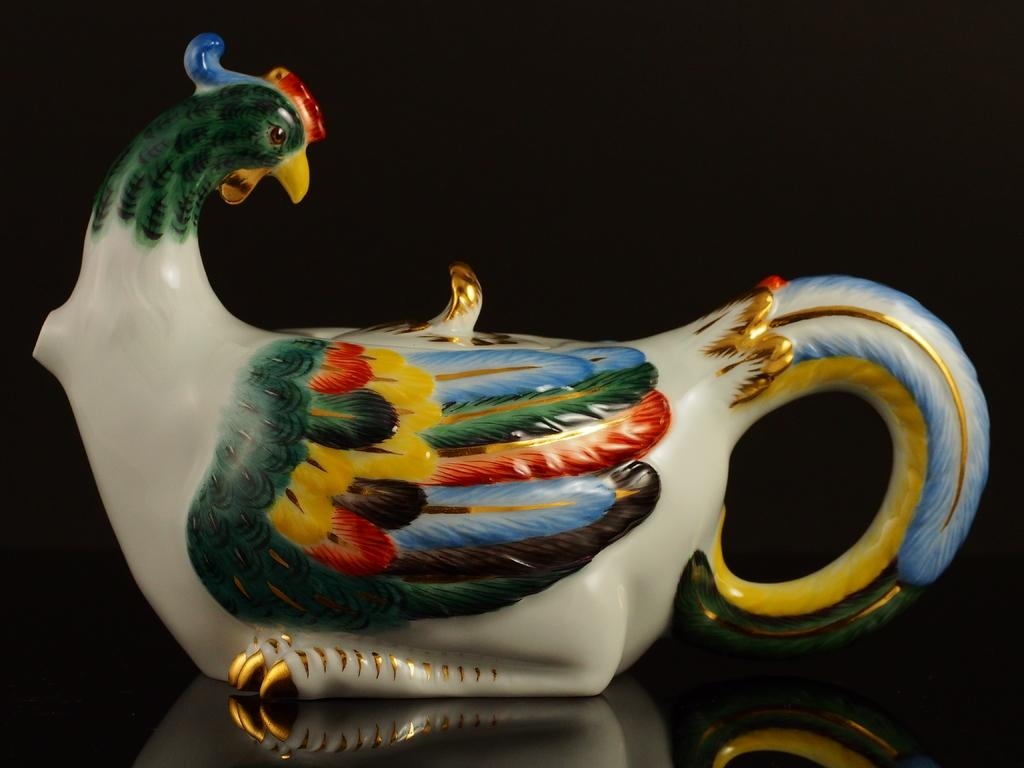What is the main object in the image? There is a bird cup in the image. Can you describe the appearance of the bird cup? The bird cup has different colors. What color is the background of the image? The background of the image is black. How many apples are hanging from the tail of the bird cup in the image? There are no apples or tails present in the image, as it features a bird cup with a black background. 